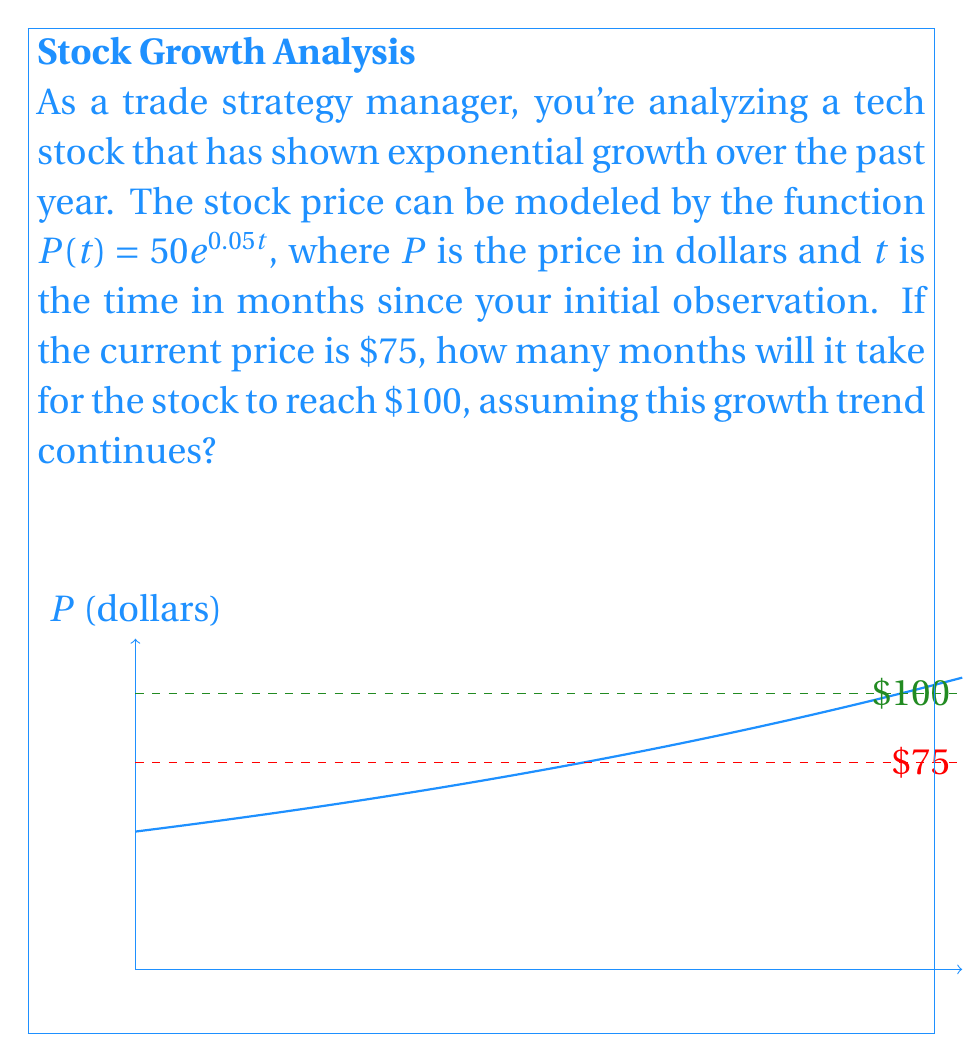Can you answer this question? To solve this problem, we'll follow these steps:

1) We start with the given function: $P(t) = 50e^{0.05t}$

2) We know that the current price is $75. Let's call the time to reach $100 as $t$. So we can set up the equation:

   $100 = 50e^{0.05t}$

3) Divide both sides by 50:

   $2 = e^{0.05t}$

4) Take the natural logarithm of both sides:

   $\ln(2) = \ln(e^{0.05t})$

5) Simplify the right side using the properties of logarithms:

   $\ln(2) = 0.05t$

6) Solve for $t$:

   $t = \frac{\ln(2)}{0.05}$

7) Calculate the result:

   $t \approx 13.86$ months

8) Since we can't have a fractional month in this context, we round up to the next whole month.

Therefore, it will take 14 months for the stock to reach $100.
Answer: 14 months 